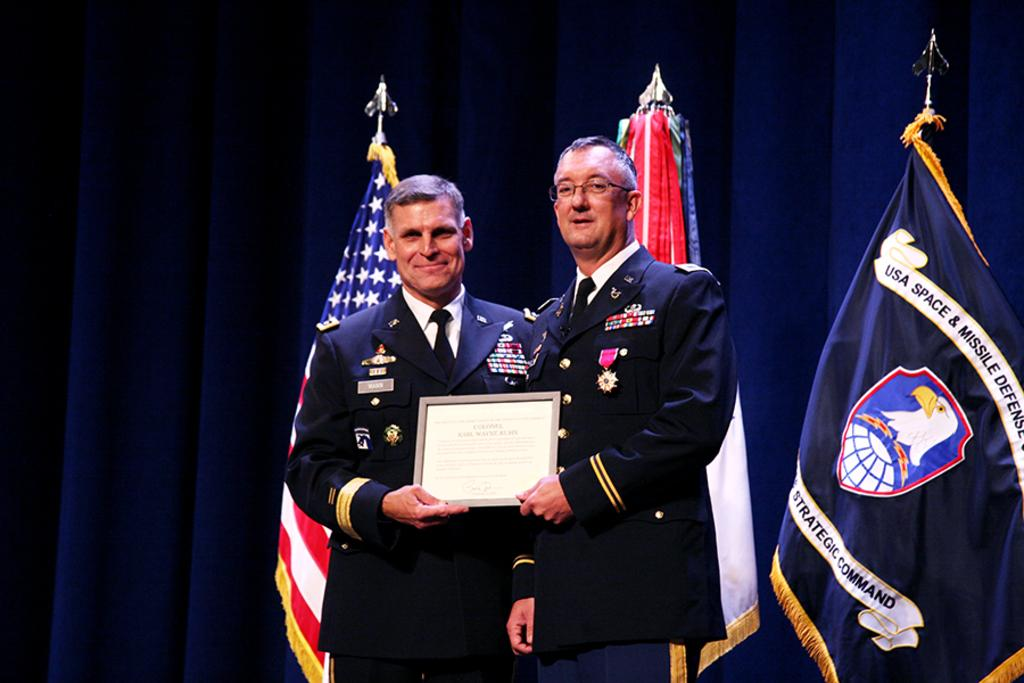<image>
Relay a brief, clear account of the picture shown. Two men standing in front of a flag which says USA Space and Missile. 